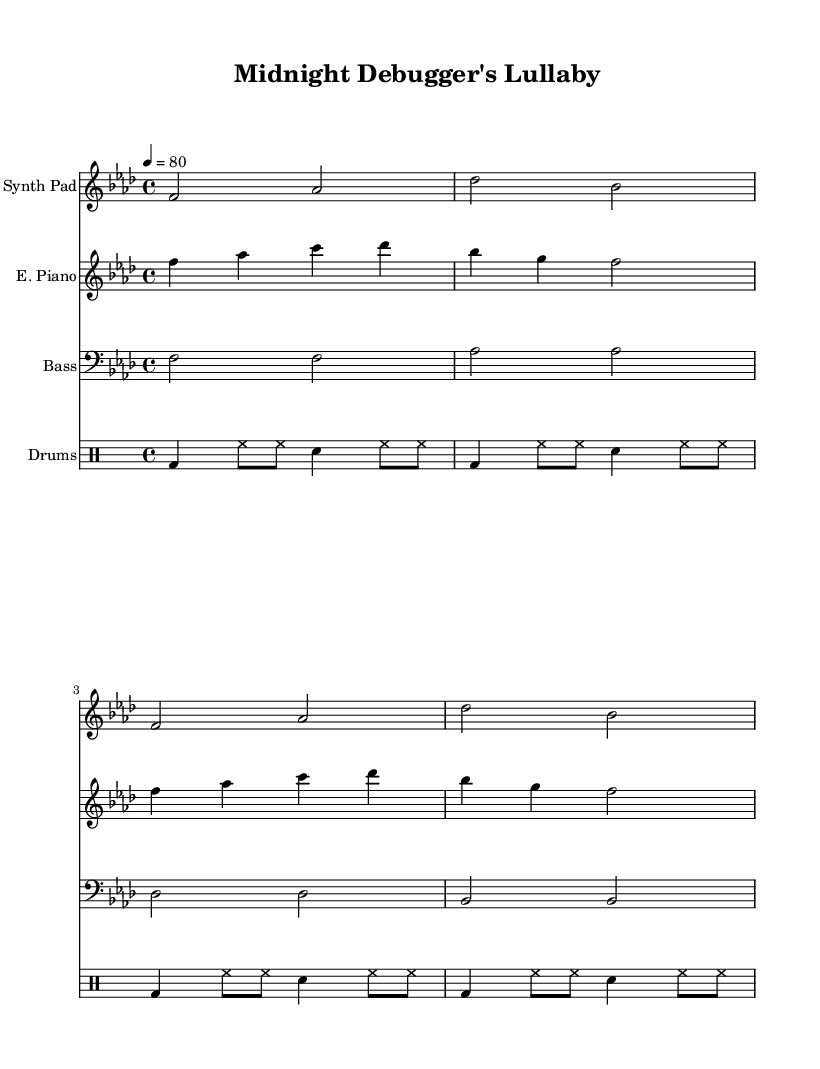What is the key signature of this music? The key signature is specified by the `\key` directive in the global settings, which indicates F minor. The key signature for F minor has four flats.
Answer: F minor What is the time signature of this music? The time signature is indicated by the `\time` directive in the global settings. It shows 4 beats per measure, which is written as 4/4.
Answer: 4/4 What is the tempo marking for this piece? The tempo is established by the `\tempo` directive. It states that the piece should be played at a speed of 80 beats per minute.
Answer: 80 How many measures are present in the synth pad part? The synth pad part is shown to contain four measures, as there are four distinct sets of notes separated by bar lines.
Answer: Four measures Which percussion instrument is used in the drum pattern? The drum pattern includes a kick drum, hi-hat, and snare. The kick drum is denoted by `bd`, the hi-hat by `hh`, and the snare by `sn`.
Answer: Kick drum, hi-hat, snare What is the groove pattern of the drum section? The drum pattern follows a consistent rhythm indicated in 4/4 time, alternating between kick and hi-hat hits, creating a regular dance groove suitable for chill-out tunes.
Answer: Regular dance groove What is the role of the bass in this music? The bass is playing sustained notes primarily focused on the root notes of the chord progression, contributing to the harmonic foundation of the piece.
Answer: Harmonic foundation 